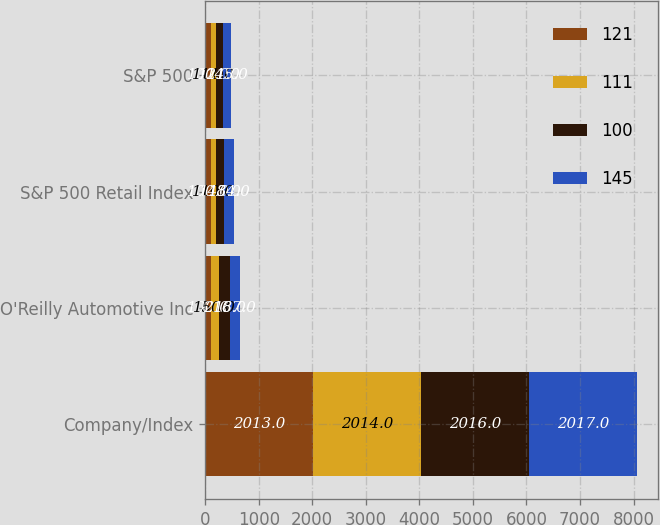Convert chart. <chart><loc_0><loc_0><loc_500><loc_500><stacked_bar_chart><ecel><fcel>Company/Index<fcel>O'Reilly Automotive Inc<fcel>S&P 500 Retail Index<fcel>S&P 500<nl><fcel>121<fcel>2013<fcel>100<fcel>100<fcel>100<nl><fcel>111<fcel>2014<fcel>150<fcel>110<fcel>111<nl><fcel>100<fcel>2016<fcel>216<fcel>143<fcel>121<nl><fcel>145<fcel>2017<fcel>187<fcel>184<fcel>145<nl></chart> 